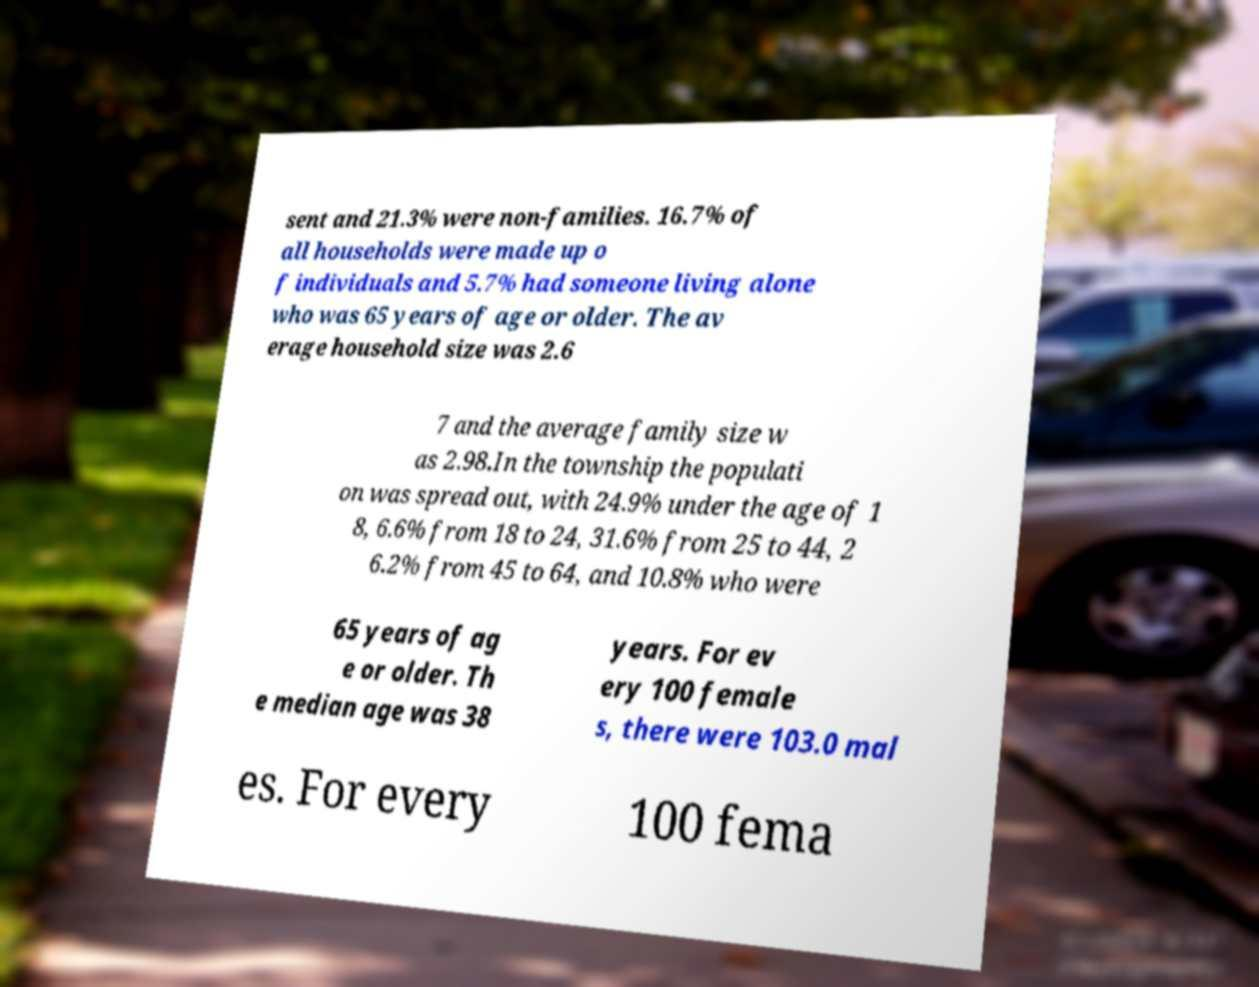Could you extract and type out the text from this image? sent and 21.3% were non-families. 16.7% of all households were made up o f individuals and 5.7% had someone living alone who was 65 years of age or older. The av erage household size was 2.6 7 and the average family size w as 2.98.In the township the populati on was spread out, with 24.9% under the age of 1 8, 6.6% from 18 to 24, 31.6% from 25 to 44, 2 6.2% from 45 to 64, and 10.8% who were 65 years of ag e or older. Th e median age was 38 years. For ev ery 100 female s, there were 103.0 mal es. For every 100 fema 